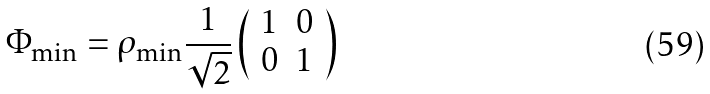<formula> <loc_0><loc_0><loc_500><loc_500>\Phi _ { \min } = \rho _ { \min } \frac { 1 } { \sqrt { 2 } } \left ( \begin{array} { c c } 1 & 0 \\ 0 & 1 \end{array} \right )</formula> 